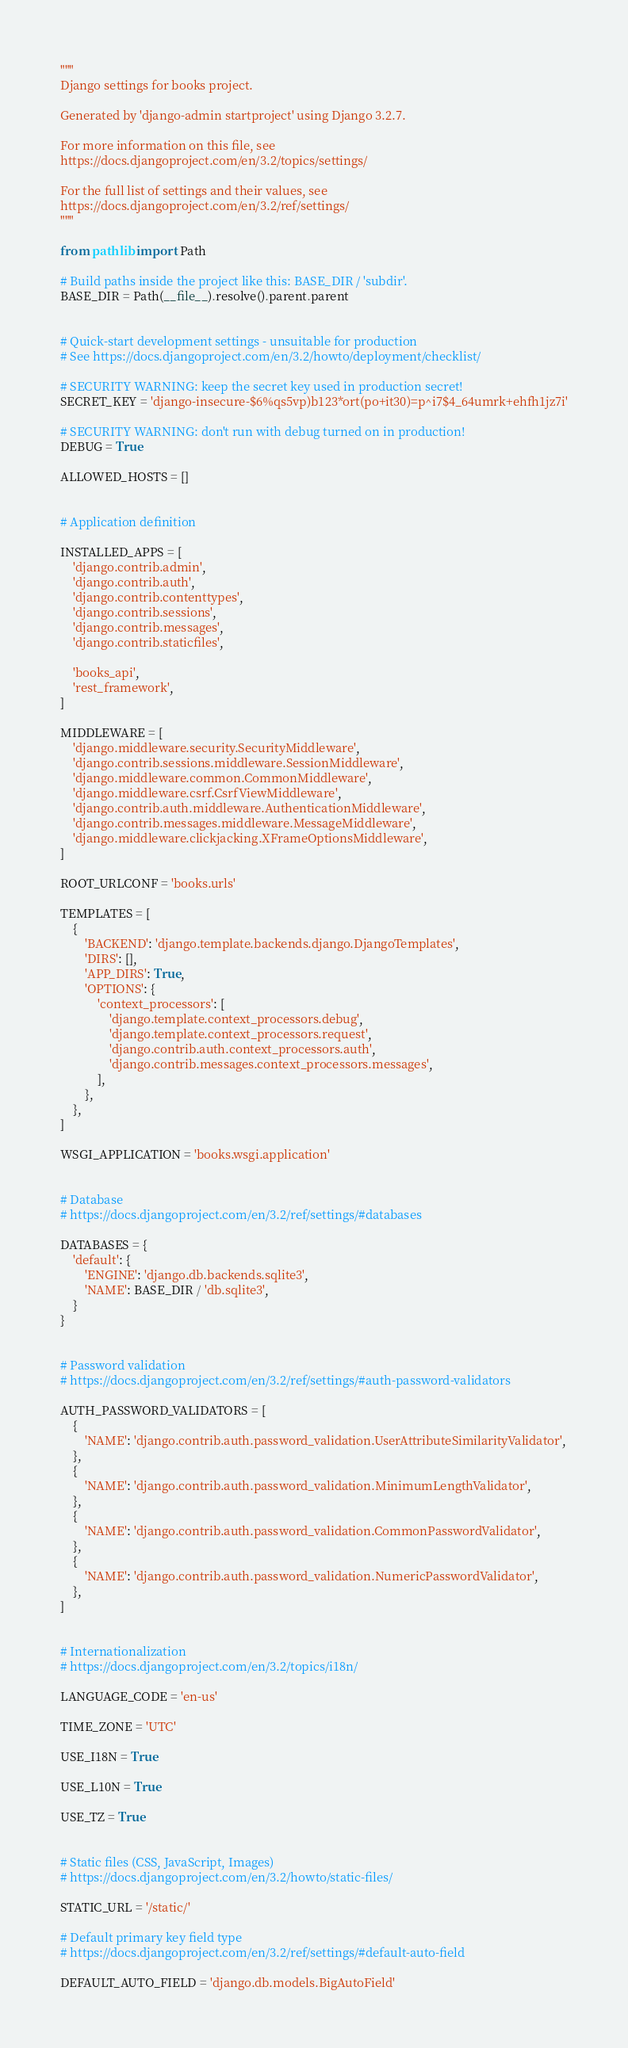Convert code to text. <code><loc_0><loc_0><loc_500><loc_500><_Python_>"""
Django settings for books project.

Generated by 'django-admin startproject' using Django 3.2.7.

For more information on this file, see
https://docs.djangoproject.com/en/3.2/topics/settings/

For the full list of settings and their values, see
https://docs.djangoproject.com/en/3.2/ref/settings/
"""

from pathlib import Path

# Build paths inside the project like this: BASE_DIR / 'subdir'.
BASE_DIR = Path(__file__).resolve().parent.parent


# Quick-start development settings - unsuitable for production
# See https://docs.djangoproject.com/en/3.2/howto/deployment/checklist/

# SECURITY WARNING: keep the secret key used in production secret!
SECRET_KEY = 'django-insecure-$6%qs5vp)b123*ort(po+it30)=p^i7$4_64umrk+ehfh1jz7i'

# SECURITY WARNING: don't run with debug turned on in production!
DEBUG = True

ALLOWED_HOSTS = []


# Application definition

INSTALLED_APPS = [
    'django.contrib.admin',
    'django.contrib.auth',
    'django.contrib.contenttypes',
    'django.contrib.sessions',
    'django.contrib.messages',
    'django.contrib.staticfiles',

    'books_api',
    'rest_framework',
]

MIDDLEWARE = [
    'django.middleware.security.SecurityMiddleware',
    'django.contrib.sessions.middleware.SessionMiddleware',
    'django.middleware.common.CommonMiddleware',
    'django.middleware.csrf.CsrfViewMiddleware',
    'django.contrib.auth.middleware.AuthenticationMiddleware',
    'django.contrib.messages.middleware.MessageMiddleware',
    'django.middleware.clickjacking.XFrameOptionsMiddleware',
]

ROOT_URLCONF = 'books.urls'

TEMPLATES = [
    {
        'BACKEND': 'django.template.backends.django.DjangoTemplates',
        'DIRS': [],
        'APP_DIRS': True,
        'OPTIONS': {
            'context_processors': [
                'django.template.context_processors.debug',
                'django.template.context_processors.request',
                'django.contrib.auth.context_processors.auth',
                'django.contrib.messages.context_processors.messages',
            ],
        },
    },
]

WSGI_APPLICATION = 'books.wsgi.application'


# Database
# https://docs.djangoproject.com/en/3.2/ref/settings/#databases

DATABASES = {
    'default': {
        'ENGINE': 'django.db.backends.sqlite3',
        'NAME': BASE_DIR / 'db.sqlite3',
    }
}


# Password validation
# https://docs.djangoproject.com/en/3.2/ref/settings/#auth-password-validators

AUTH_PASSWORD_VALIDATORS = [
    {
        'NAME': 'django.contrib.auth.password_validation.UserAttributeSimilarityValidator',
    },
    {
        'NAME': 'django.contrib.auth.password_validation.MinimumLengthValidator',
    },
    {
        'NAME': 'django.contrib.auth.password_validation.CommonPasswordValidator',
    },
    {
        'NAME': 'django.contrib.auth.password_validation.NumericPasswordValidator',
    },
]


# Internationalization
# https://docs.djangoproject.com/en/3.2/topics/i18n/

LANGUAGE_CODE = 'en-us'

TIME_ZONE = 'UTC'

USE_I18N = True

USE_L10N = True

USE_TZ = True


# Static files (CSS, JavaScript, Images)
# https://docs.djangoproject.com/en/3.2/howto/static-files/

STATIC_URL = '/static/'

# Default primary key field type
# https://docs.djangoproject.com/en/3.2/ref/settings/#default-auto-field

DEFAULT_AUTO_FIELD = 'django.db.models.BigAutoField'
</code> 